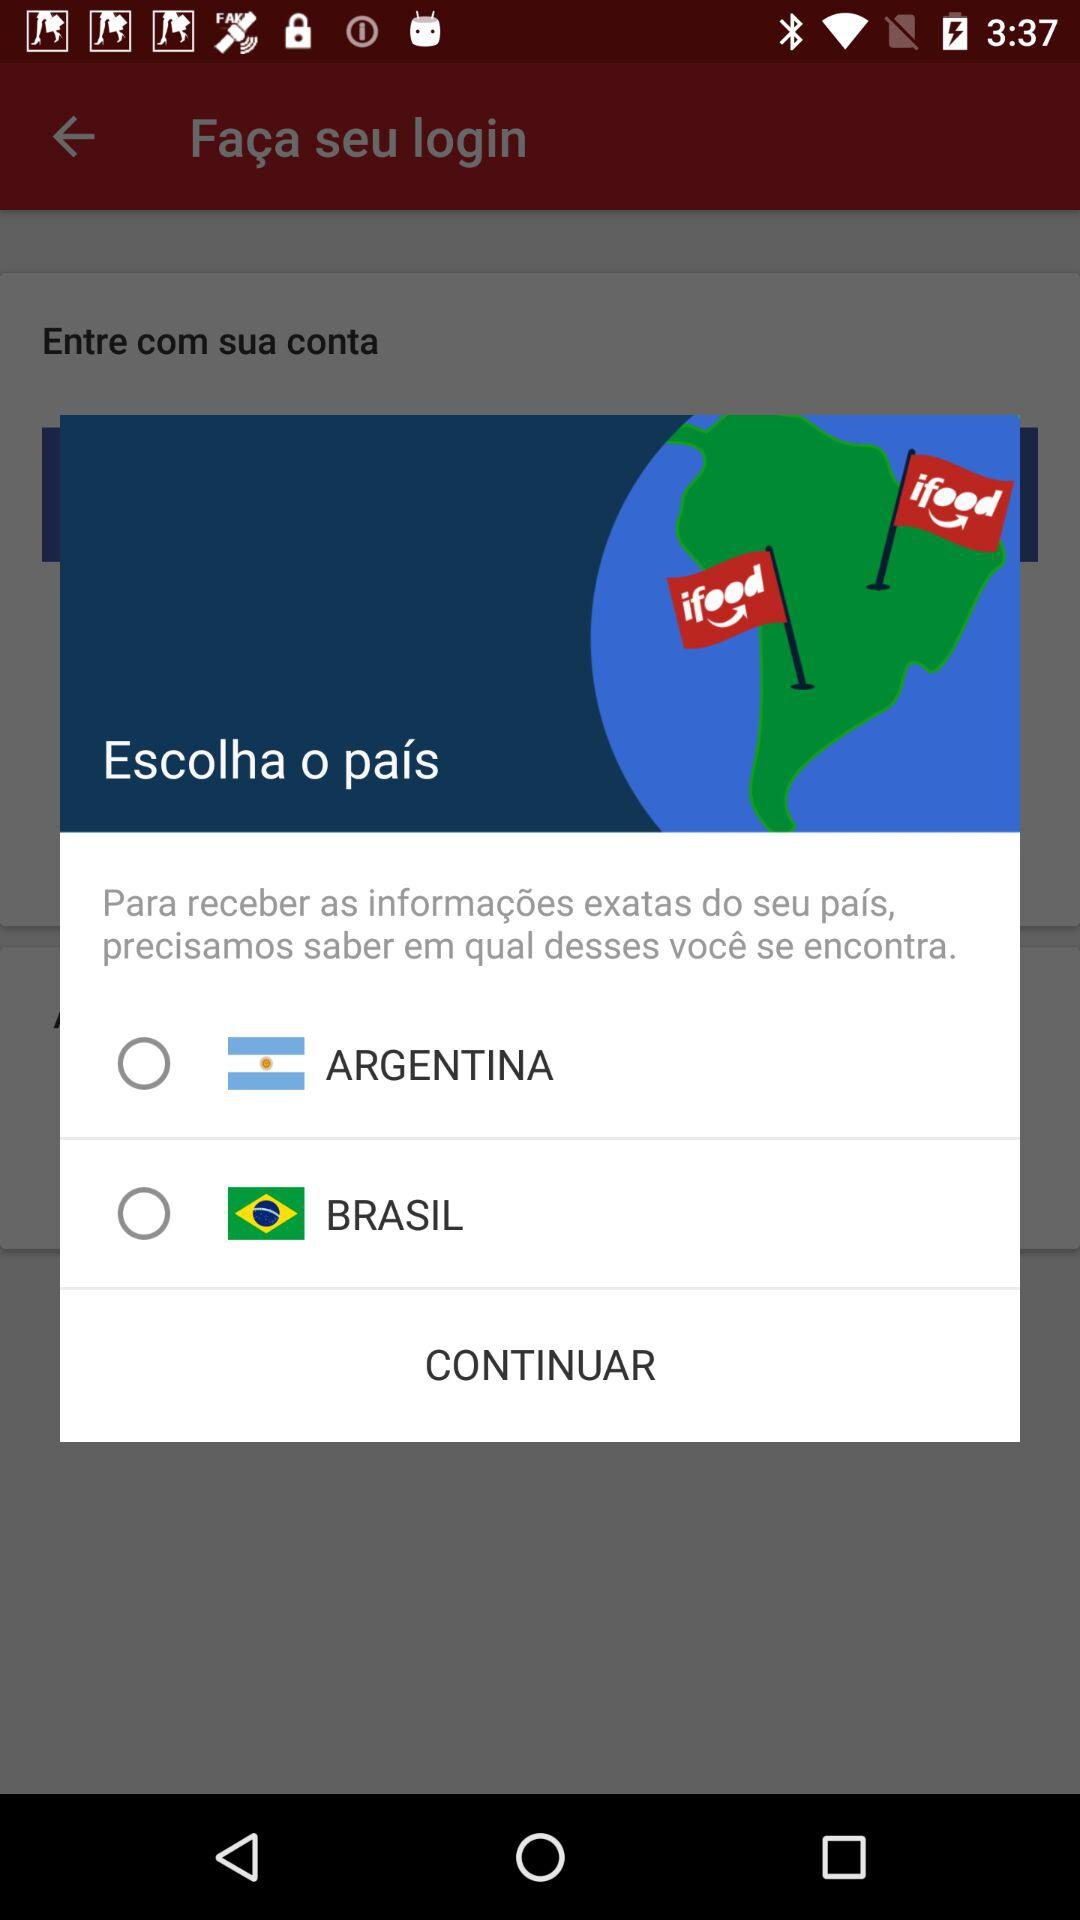How many countries are available for selection?
Answer the question using a single word or phrase. 2 